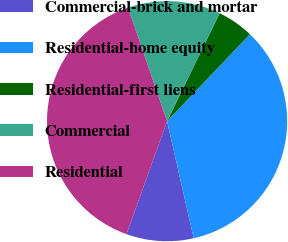<chart> <loc_0><loc_0><loc_500><loc_500><pie_chart><fcel>Commercial-brick and mortar<fcel>Residential-home equity<fcel>Residential-first liens<fcel>Commercial<fcel>Residential<nl><fcel>9.05%<fcel>34.33%<fcel>4.9%<fcel>12.49%<fcel>39.23%<nl></chart> 